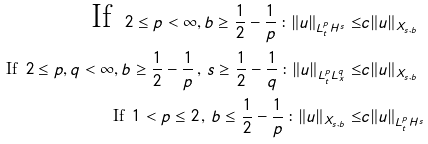Convert formula to latex. <formula><loc_0><loc_0><loc_500><loc_500>\text {If } \, 2 \leq p < \infty , b \geq \frac { 1 } { 2 } - \frac { 1 } { p } \, \colon \| u \| _ { L ^ { p } _ { t } H ^ { s } } \leq & c \| u \| _ { X _ { s , b } } \\ \text {If } \, 2 \leq p , q < \infty , b \geq \frac { 1 } { 2 } - \frac { 1 } { p } \, , \, s \geq \frac { 1 } { 2 } - \frac { 1 } { q } \, \colon \| u \| _ { L ^ { p } _ { t } L ^ { q } _ { x } } \leq & c \| u \| _ { X _ { s , b } } \\ \text {If } \, 1 < p \leq 2 \, , \, b \leq \frac { 1 } { 2 } - \frac { 1 } { p } \, \colon \| u \| _ { X _ { s , b } } \leq & c \| u \| _ { L ^ { p } _ { t } H ^ { s } }</formula> 